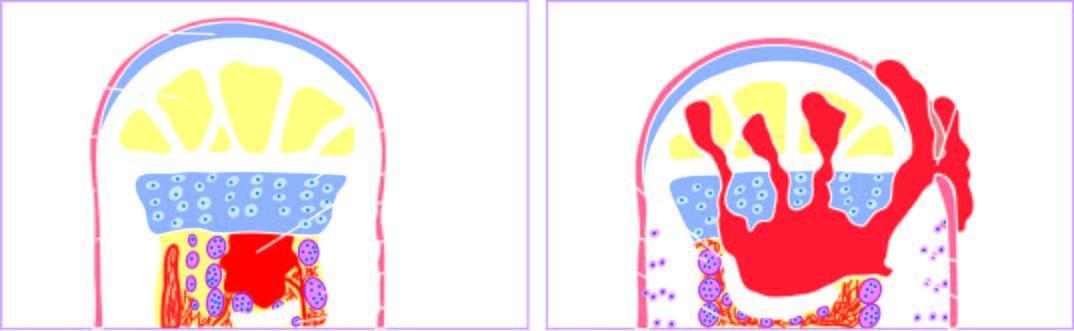s the formation of viable new reactive bone surrounding the sequestrum called involucrum?
Answer the question using a single word or phrase. Yes 